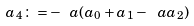Convert formula to latex. <formula><loc_0><loc_0><loc_500><loc_500>a _ { 4 } \colon = - \ a ( a _ { 0 } + a _ { 1 } - \ a a _ { 2 } )</formula> 